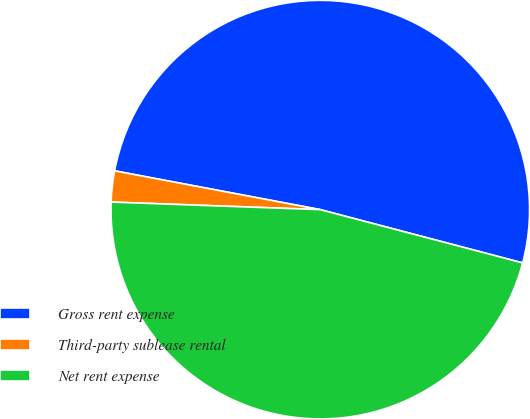<chart> <loc_0><loc_0><loc_500><loc_500><pie_chart><fcel>Gross rent expense<fcel>Third-party sublease rental<fcel>Net rent expense<nl><fcel>51.13%<fcel>2.39%<fcel>46.48%<nl></chart> 